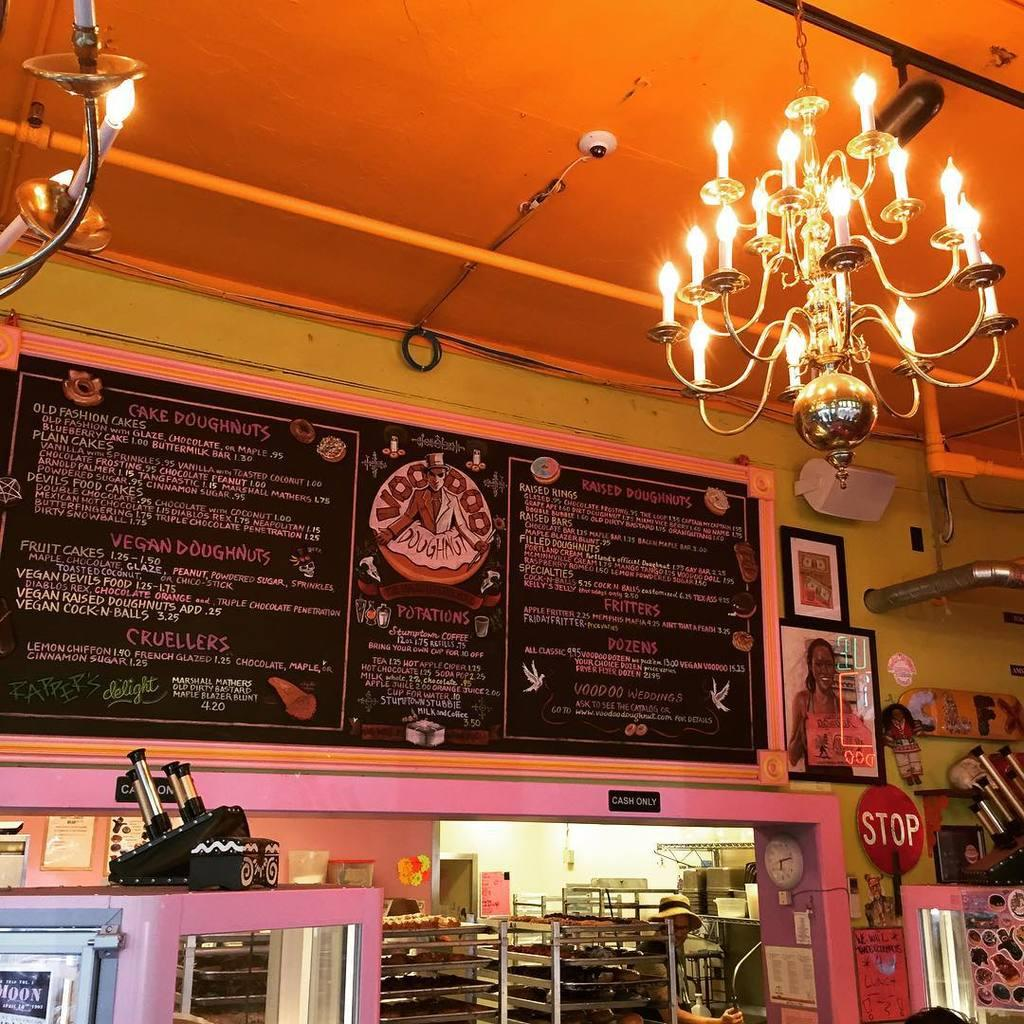What type of establishment is the image taken in? The image appears to be taken in a restaurant. What can be seen on the wall in the image? There is a menu board on the wall. What is featured on the right side of the menu board? The menu board has photographs on the right side. What is located below the menu board? There are racks below the menu board. What type of lighting fixture is hanging from the ceiling? There is a chandelier hanging from the ceiling. What year is depicted in the bed on the wall? There is no bed present in the image; it features a menu board with photographs. How does the acoustics of the restaurant affect the conversation in the image? The image does not provide information about the acoustics of the restaurant or the conversation taking place. 